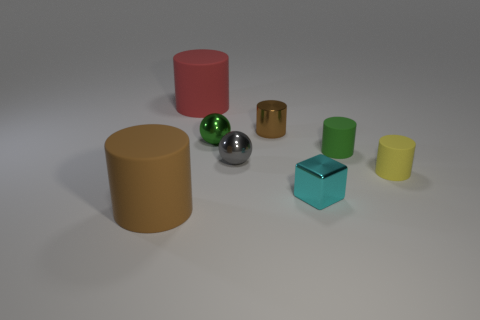Is there anything else that has the same shape as the big red matte object?
Your answer should be very brief. Yes. There is another thing that is the same shape as the gray object; what color is it?
Provide a short and direct response. Green. What number of objects are either tiny cyan metallic cylinders or large matte cylinders in front of the small cyan object?
Your answer should be very brief. 1. Are there fewer brown metal cylinders that are in front of the green shiny sphere than cyan matte spheres?
Provide a succinct answer. No. What is the size of the brown cylinder to the left of the big matte object behind the brown cylinder on the left side of the red rubber cylinder?
Keep it short and to the point. Large. The matte thing that is both in front of the small gray sphere and on the left side of the tiny metallic cylinder is what color?
Make the answer very short. Brown. How many tiny matte things are there?
Provide a short and direct response. 2. Is there anything else that has the same size as the cyan metallic object?
Provide a short and direct response. Yes. Do the cube and the large red cylinder have the same material?
Offer a terse response. No. Do the green object that is left of the tiny green rubber cylinder and the brown cylinder to the left of the red matte thing have the same size?
Keep it short and to the point. No. 